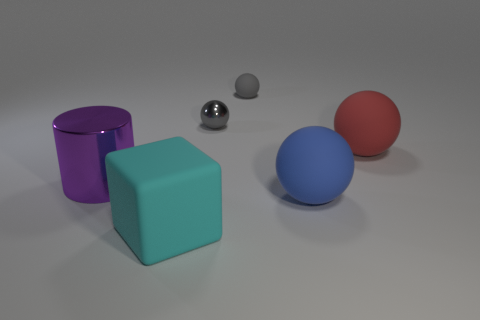What number of other objects are the same size as the gray matte ball?
Your answer should be compact. 1. Are there any large brown matte objects that have the same shape as the gray shiny object?
Offer a terse response. No. What is the shape of the cyan object that is the same size as the purple cylinder?
Make the answer very short. Cube. How many objects are rubber objects that are in front of the big cylinder or blue rubber balls?
Your answer should be very brief. 2. Is the color of the small metal thing the same as the small matte thing?
Provide a short and direct response. Yes. There is a matte thing left of the tiny metallic sphere; how big is it?
Offer a very short reply. Large. Are there any balls that have the same size as the purple cylinder?
Offer a very short reply. Yes. Does the thing that is to the left of the cyan matte block have the same size as the small gray shiny thing?
Offer a very short reply. No. How big is the purple metal cylinder?
Your answer should be compact. Large. The metal thing that is on the right side of the large object that is in front of the big blue rubber ball in front of the metal cylinder is what color?
Provide a succinct answer. Gray. 